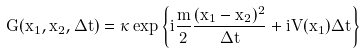Convert formula to latex. <formula><loc_0><loc_0><loc_500><loc_500>G ( x _ { 1 } , x _ { 2 } , \Delta t ) = \kappa \exp \left \{ i \frac { m } { 2 } \frac { ( x _ { 1 } - x _ { 2 } ) ^ { 2 } } { \Delta t } + i V ( x _ { 1 } ) \Delta t \right \}</formula> 